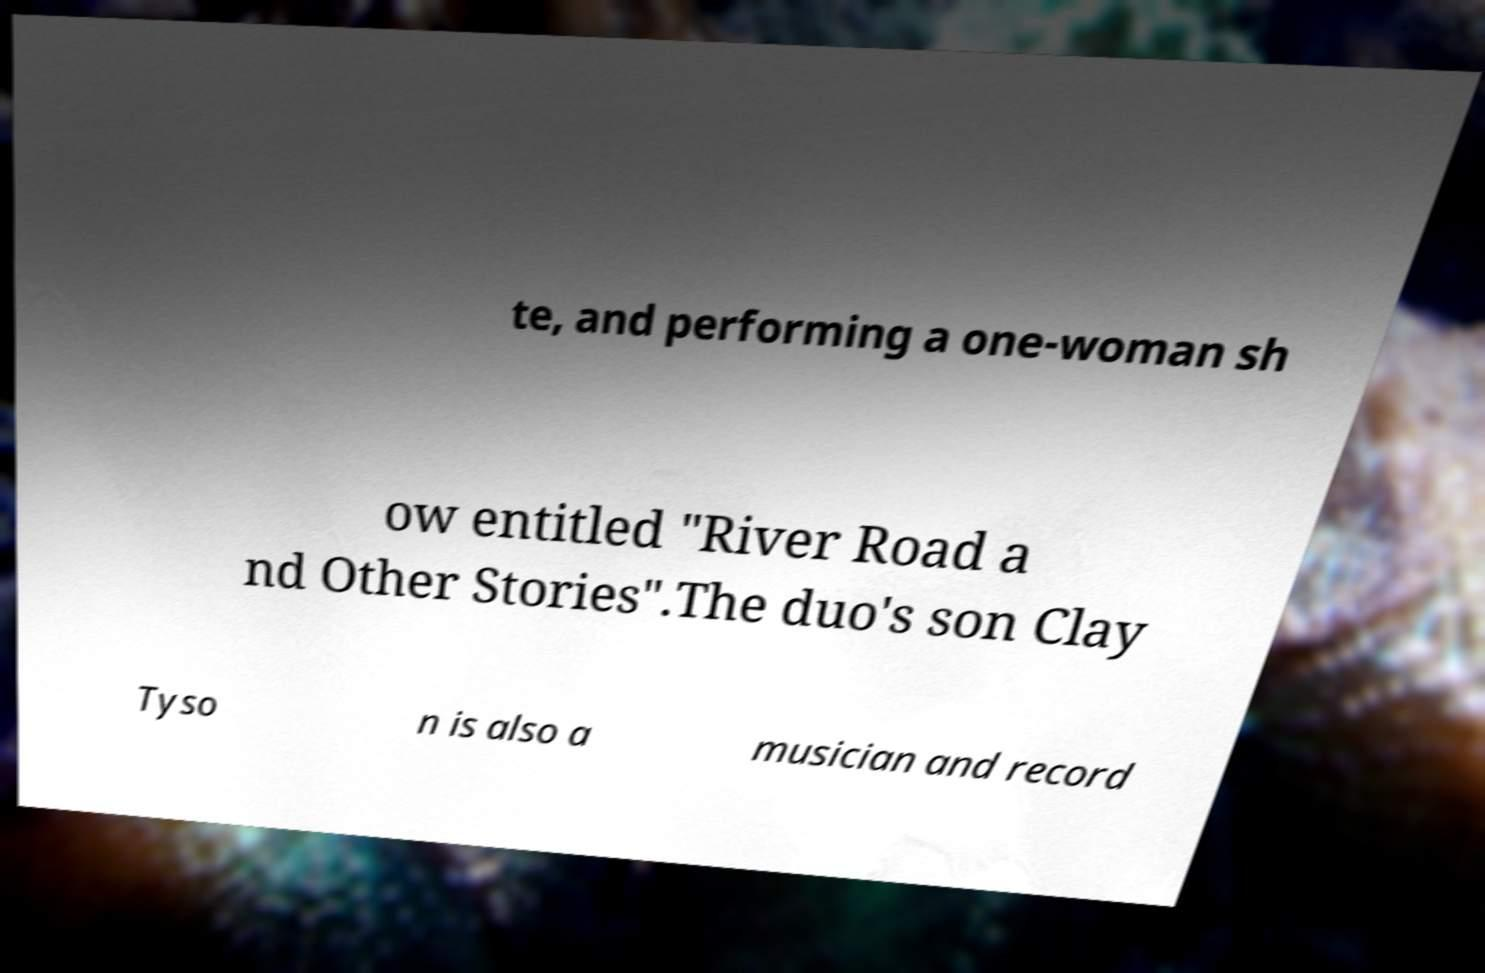Could you extract and type out the text from this image? te, and performing a one-woman sh ow entitled "River Road a nd Other Stories".The duo's son Clay Tyso n is also a musician and record 